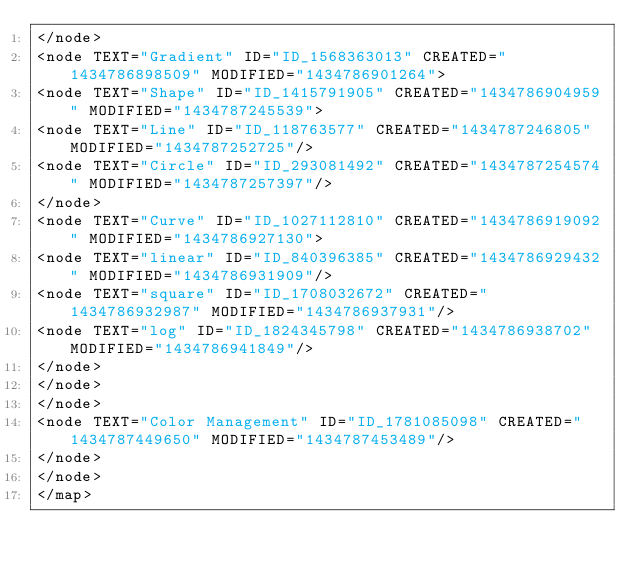<code> <loc_0><loc_0><loc_500><loc_500><_ObjectiveC_></node>
<node TEXT="Gradient" ID="ID_1568363013" CREATED="1434786898509" MODIFIED="1434786901264">
<node TEXT="Shape" ID="ID_1415791905" CREATED="1434786904959" MODIFIED="1434787245539">
<node TEXT="Line" ID="ID_118763577" CREATED="1434787246805" MODIFIED="1434787252725"/>
<node TEXT="Circle" ID="ID_293081492" CREATED="1434787254574" MODIFIED="1434787257397"/>
</node>
<node TEXT="Curve" ID="ID_1027112810" CREATED="1434786919092" MODIFIED="1434786927130">
<node TEXT="linear" ID="ID_840396385" CREATED="1434786929432" MODIFIED="1434786931909"/>
<node TEXT="square" ID="ID_1708032672" CREATED="1434786932987" MODIFIED="1434786937931"/>
<node TEXT="log" ID="ID_1824345798" CREATED="1434786938702" MODIFIED="1434786941849"/>
</node>
</node>
</node>
<node TEXT="Color Management" ID="ID_1781085098" CREATED="1434787449650" MODIFIED="1434787453489"/>
</node>
</node>
</map>
</code> 